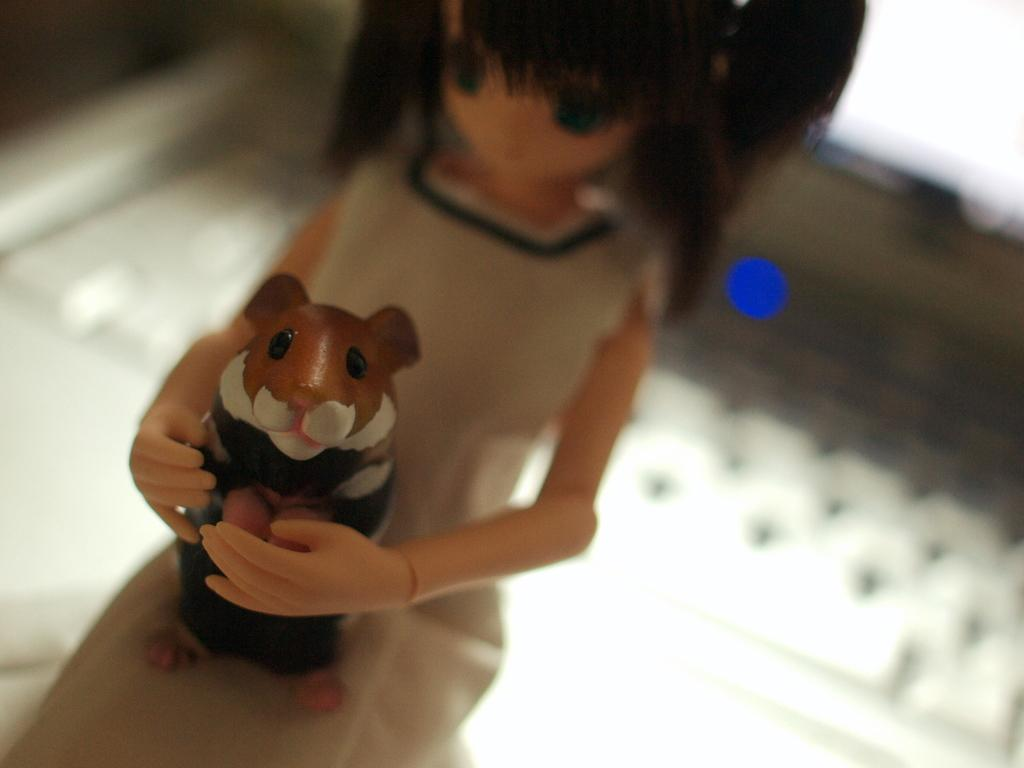What object in the image is designed for play or entertainment? There is a toy in the image. What type of watch is the toy wearing in the image? There is no watch present in the image, as the main subject is a toy, not a person or an object that would typically wear a watch. 